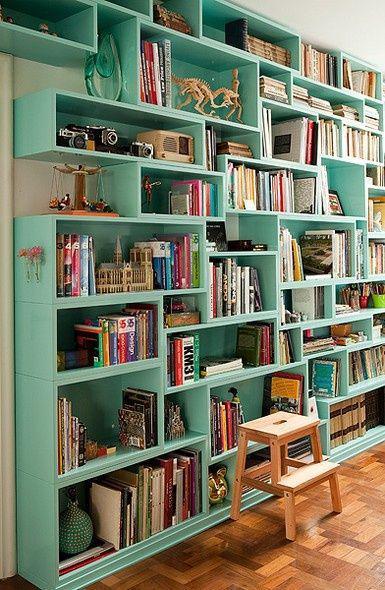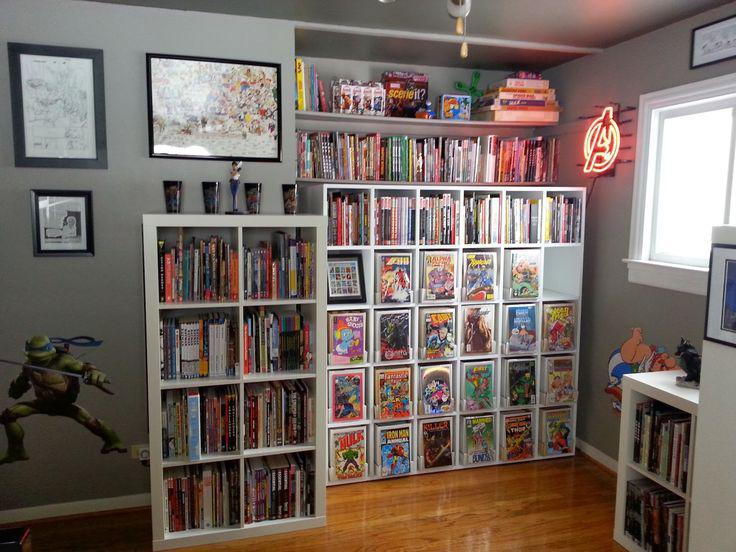The first image is the image on the left, the second image is the image on the right. For the images displayed, is the sentence "The bookshelves in at least one image angle around the corner of room, so that they  extend outward on two walls." factually correct? Answer yes or no. No. 